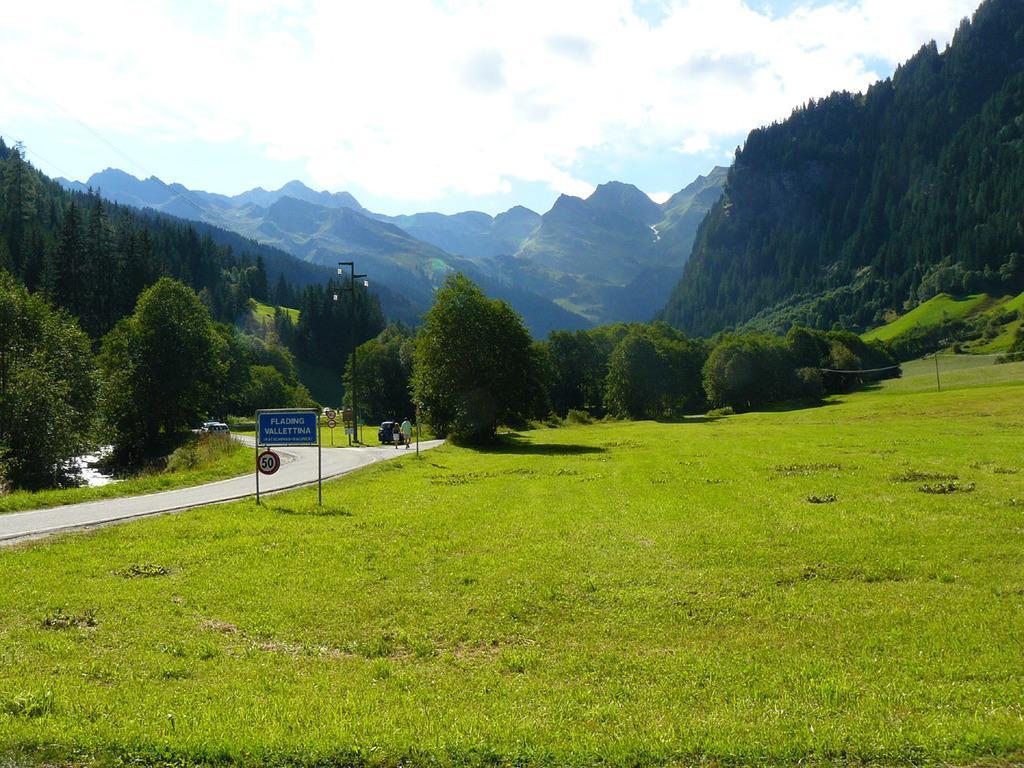Could you give a brief overview of what you see in this image? In this picture we can see the grass, name board, sign boards, two people and vehicles on the road, pole, trees, mountains and in the background we can see the sky with clouds. 